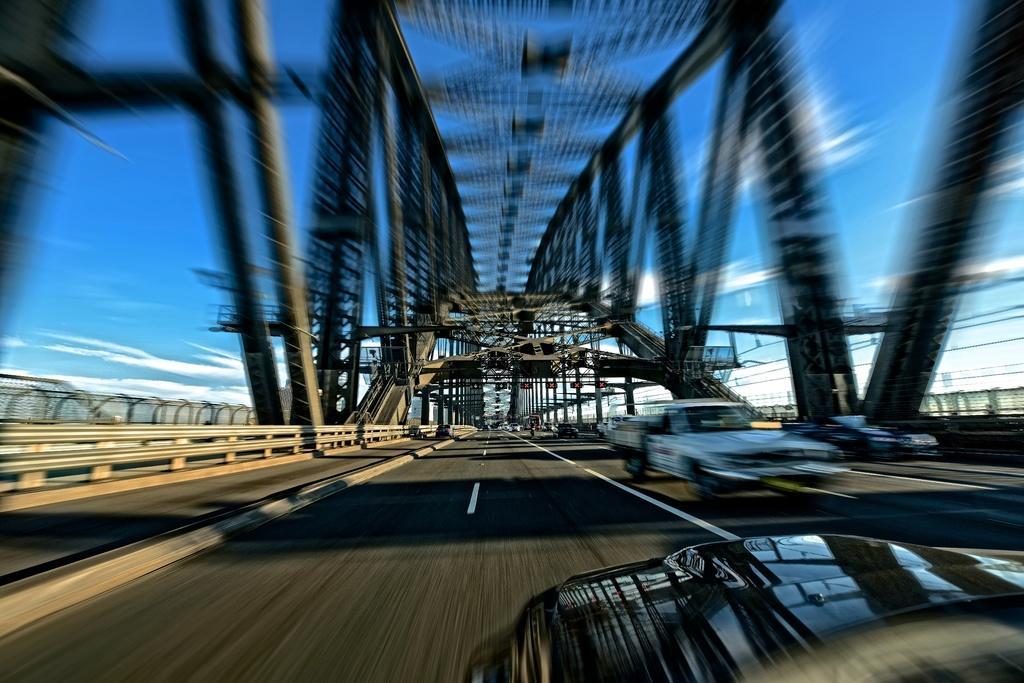Please provide a concise description of this image. As we can see in the image there are poles, vehicles, fence, sky and clouds. The image is little blurred. 